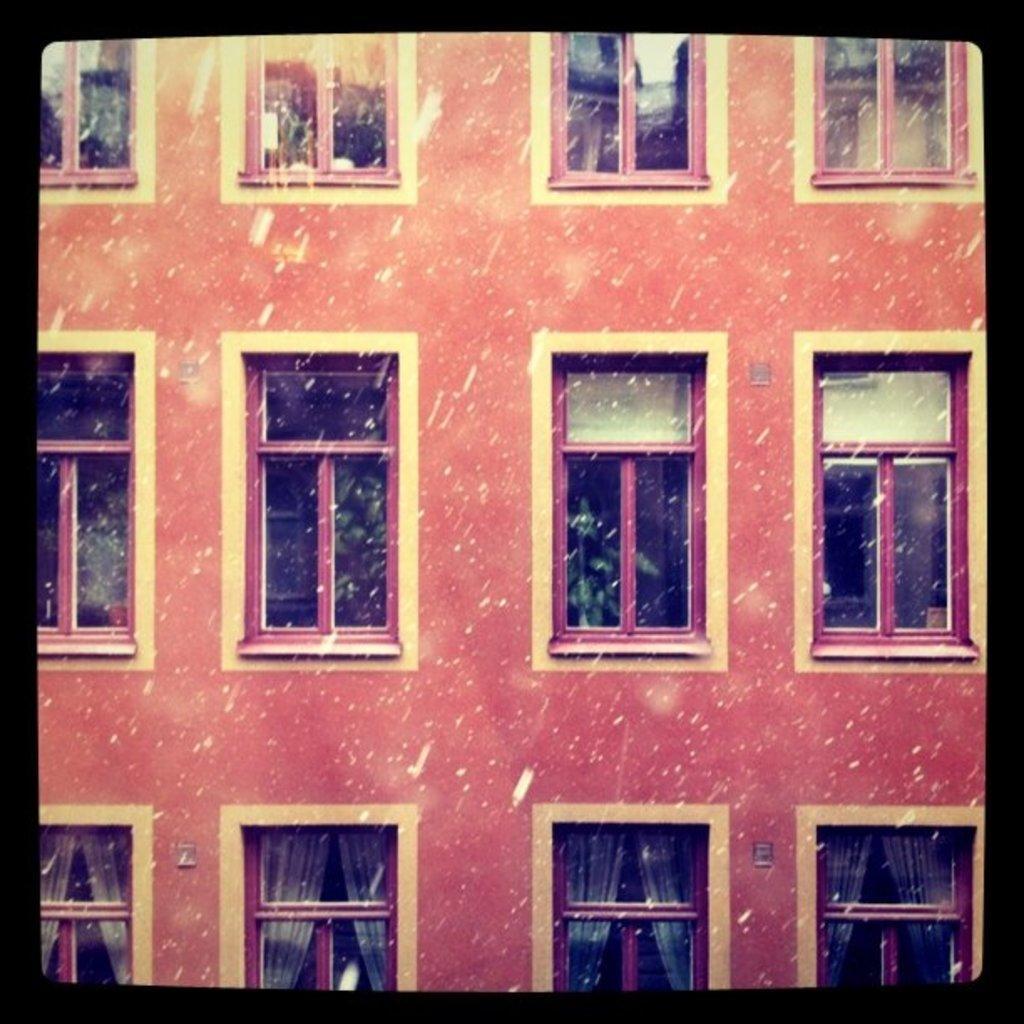In one or two sentences, can you explain what this image depicts? This is an edited image. In this image I can see a part of a building. There are many windows. Behind the windows, I can see the curtains. 